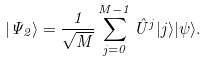Convert formula to latex. <formula><loc_0><loc_0><loc_500><loc_500>| \Psi _ { 2 } \rangle = \frac { 1 } { \sqrt { M } } \sum _ { j = 0 } ^ { M - 1 } \hat { U } ^ { j } | j \rangle | \psi \rangle .</formula> 